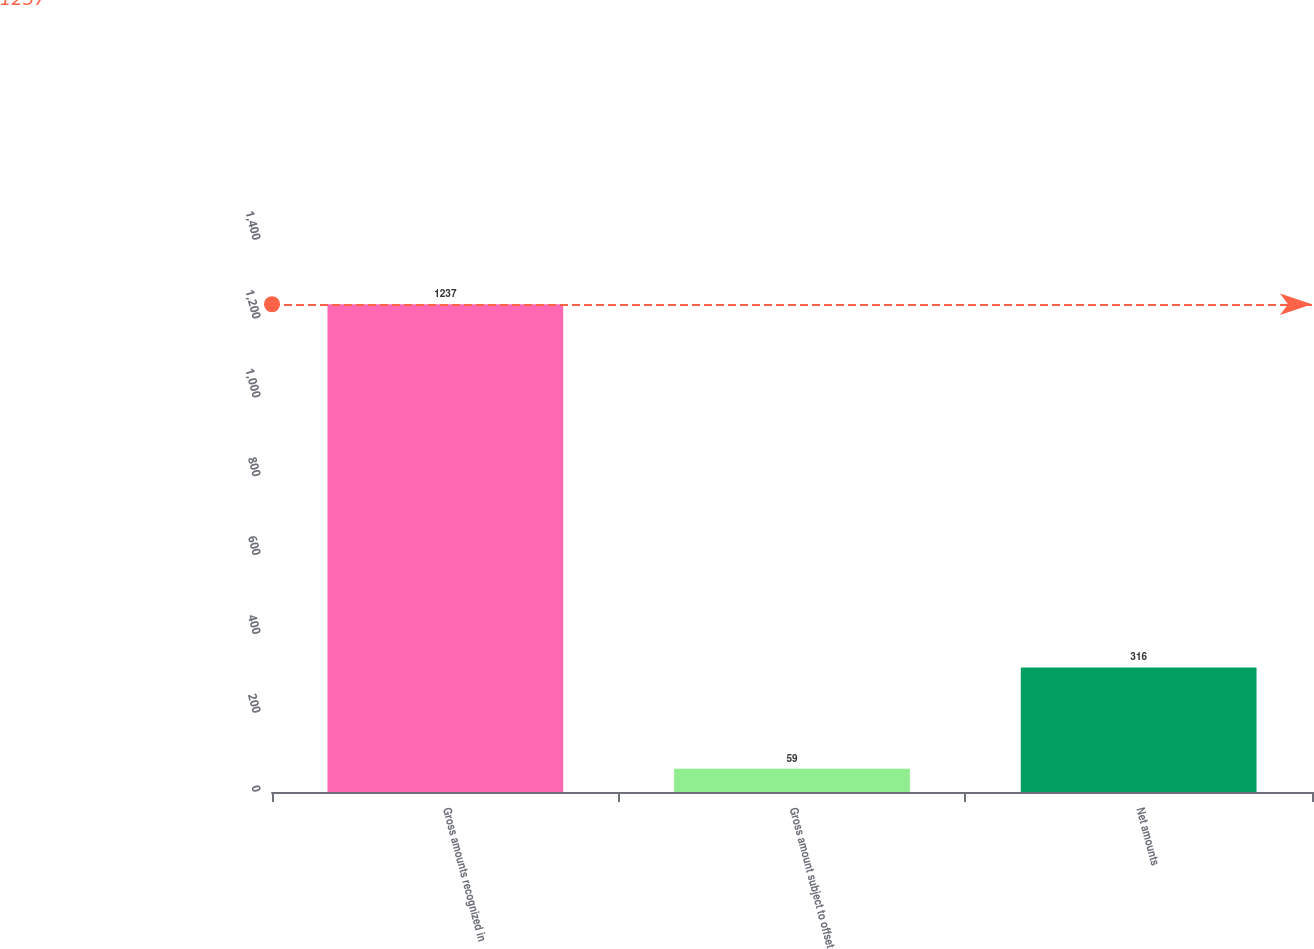Convert chart. <chart><loc_0><loc_0><loc_500><loc_500><bar_chart><fcel>Gross amounts recognized in<fcel>Gross amount subject to offset<fcel>Net amounts<nl><fcel>1237<fcel>59<fcel>316<nl></chart> 